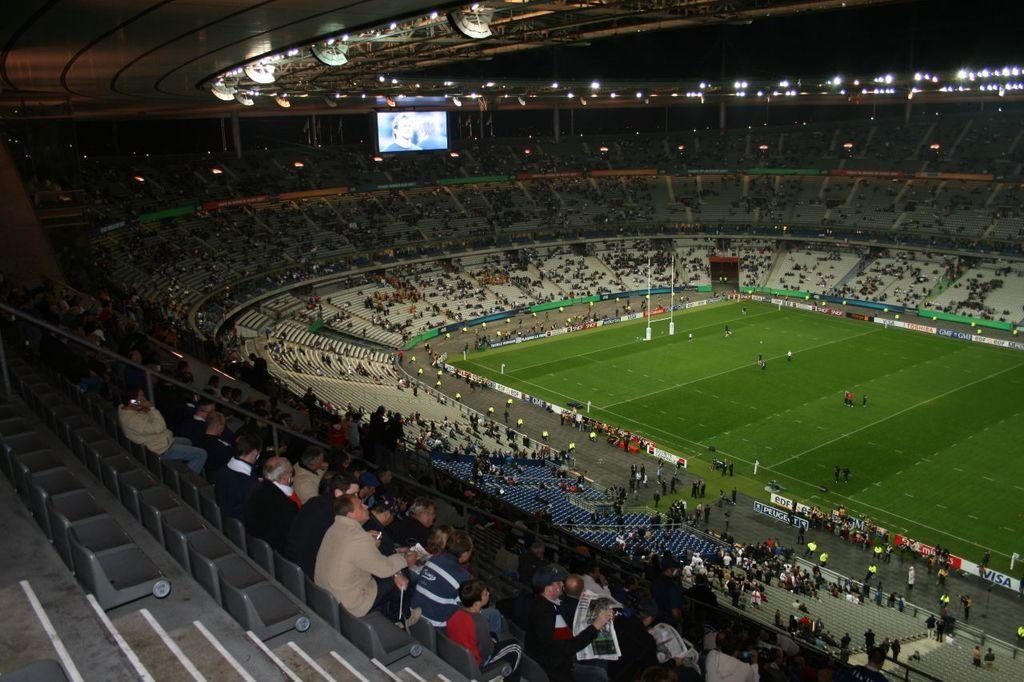How many people are in the image? There is a group of people in the image. What are the people doing in the image? The people are sitting on chairs. What other objects can be seen in the image besides the people? There are poles, colorful boards, lights, and a screen in the image. What type of cub is visible in the image? There is no cub present in the image. How does the image change when viewed from different angles? The image itself does not change when viewed from different angles; it remains the same. 